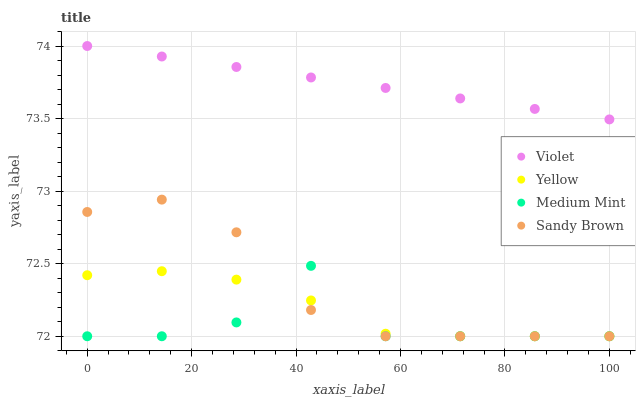Does Medium Mint have the minimum area under the curve?
Answer yes or no. Yes. Does Violet have the maximum area under the curve?
Answer yes or no. Yes. Does Sandy Brown have the minimum area under the curve?
Answer yes or no. No. Does Sandy Brown have the maximum area under the curve?
Answer yes or no. No. Is Violet the smoothest?
Answer yes or no. Yes. Is Medium Mint the roughest?
Answer yes or no. Yes. Is Sandy Brown the smoothest?
Answer yes or no. No. Is Sandy Brown the roughest?
Answer yes or no. No. Does Medium Mint have the lowest value?
Answer yes or no. Yes. Does Violet have the lowest value?
Answer yes or no. No. Does Violet have the highest value?
Answer yes or no. Yes. Does Sandy Brown have the highest value?
Answer yes or no. No. Is Sandy Brown less than Violet?
Answer yes or no. Yes. Is Violet greater than Yellow?
Answer yes or no. Yes. Does Medium Mint intersect Yellow?
Answer yes or no. Yes. Is Medium Mint less than Yellow?
Answer yes or no. No. Is Medium Mint greater than Yellow?
Answer yes or no. No. Does Sandy Brown intersect Violet?
Answer yes or no. No. 